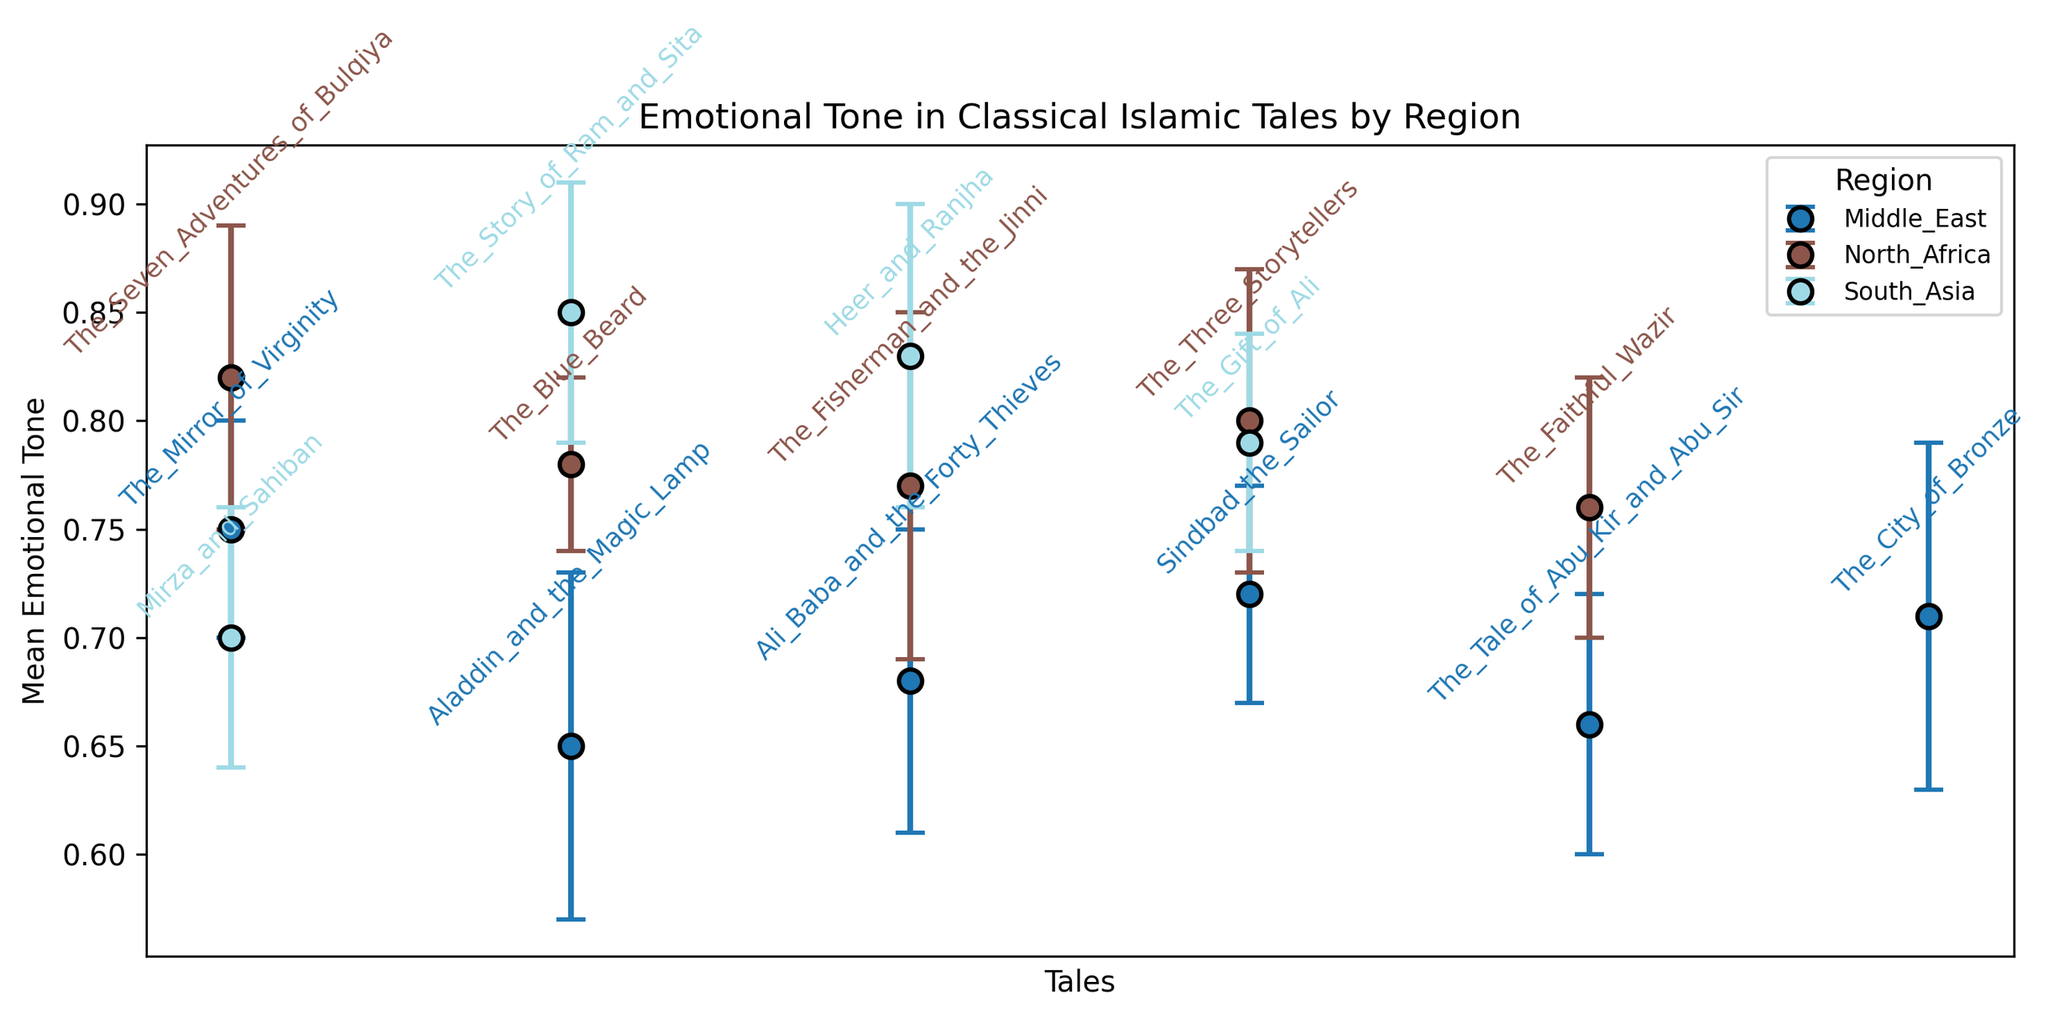Which region has the tale with the highest mean emotional tone? The tale with the highest mean emotional tone is "The Story of Ram and Sita" with a mean of 0.85. It belongs to the South Asia region.
Answer: South Asia Between 'The Tale of Abu Kir and Abu Sir' and 'Aladdin and the Magic Lamp,' which tale has lower emotional tone, and which region are they from? 'Aladdin and the Magic Lamp' has a mean tone of 0.65 while 'The Tale of Abu Kir and Abu Sir' has a mean tone of 0.66. Hence, 'Aladdin and the Magic Lamp' has a lower emotional tone, both tales are from the Middle East region.
Answer: 'Aladdin and the Magic Lamp', Middle East What is the average standard deviation of the tales from the Middle East? The standard deviations for the Middle East tales are 0.05, 0.08, 0.07, 0.05, 0.06, and 0.08. The average is calculated as (0.05 + 0.08 + 0.07 + 0.05 + 0.06 + 0.08)/6 = 0.065.
Answer: 0.065 Which region has the most consistent emotional tone, indicated by the smallest average standard deviation? Calculating the average standard deviation for each region: Middle East (0.065), North Africa (0.06), South Asia (0.06). Both North Africa and South Asia have average standard deviations of 0.06, making them the most consistent.
Answer: North Africa and South Asia Compare the emotional tones of 'The Fisherman and the Jinni' and 'The Faithful Wazir.' Which tale has a higher emotional tone, and is the difference significant based on their standard deviations? 'The Fisherman and the Jinni' has a mean emotional tone of 0.77 with a standard deviation of 0.08, while 'The Faithful Wazir' has a mean of 0.76 and a standard deviation of 0.06. The difference (0.77 - 0.76) is 0.01. The overlap in standard deviations suggests the difference is not significant.
Answer: No, the difference is not significant What is the combined mean emotional tone of 'The Mirror of Virginity' and 'Sindbad the Sailor'? Adding their mean emotional tones: 0.75 (The Mirror of Virginity) + 0.72 (Sindbad the Sailor) = 1.47.
Answer: 1.47 Identify the tale from North Africa with the highest standard deviation in emotional tone and state its value. 'The Fisherman and the Jinni' from North Africa has the highest standard deviation in emotional tone, which is 0.08.
Answer: 'The Fisherman and the Jinni', 0.08 Is the mean emotional tone for 'Heer and Ranjha' higher than that for 'The Faithful Wazir'? 'Heer and Ranjha' has a mean emotional tone of 0.83, which is higher than 'The Faithful Wazir,' which has a mean of 0.76.
Answer: Yes Which tale has the second-lowest mean emotional tone across all regions, and what is its value? 'The Tale of Abu Kir and Abu Sir' has the second-lowest mean emotional tone of 0.66.
Answer: 'The Tale of Abu Kir and Abu Sir', 0.66 